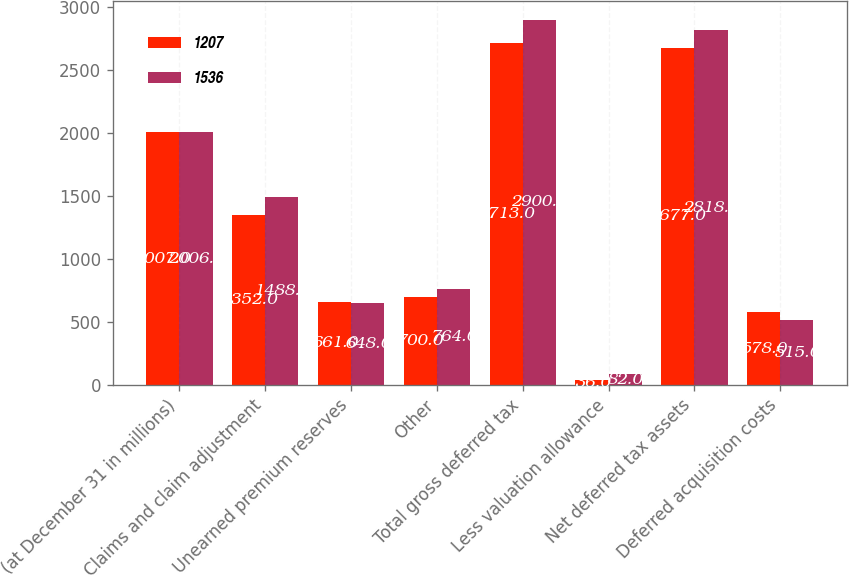Convert chart to OTSL. <chart><loc_0><loc_0><loc_500><loc_500><stacked_bar_chart><ecel><fcel>(at December 31 in millions)<fcel>Claims and claim adjustment<fcel>Unearned premium reserves<fcel>Other<fcel>Total gross deferred tax<fcel>Less valuation allowance<fcel>Net deferred tax assets<fcel>Deferred acquisition costs<nl><fcel>1207<fcel>2007<fcel>1352<fcel>661<fcel>700<fcel>2713<fcel>36<fcel>2677<fcel>578<nl><fcel>1536<fcel>2006<fcel>1488<fcel>648<fcel>764<fcel>2900<fcel>82<fcel>2818<fcel>515<nl></chart> 